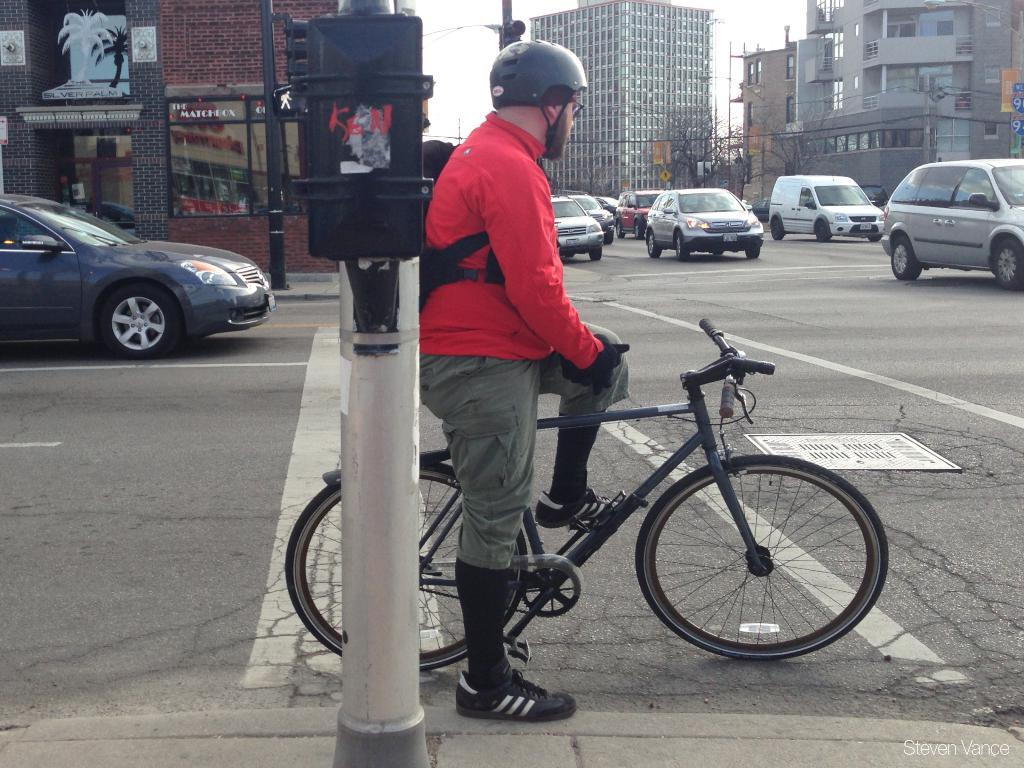What is the main subject in the center of the image? There is a person sitting on a bicycle in the center of the image. What type of vehicles can be seen on the right side of the image? There are cars on the right side of the image. Can you describe the vehicle on the left side of the image? There is a car on the left side of the image. What can be seen in the background of the image? There are buildings visible in the background of the image. What disease is the person on the bicycle suffering from in the image? There is no indication of any disease in the image; the person is simply sitting on a bicycle. 